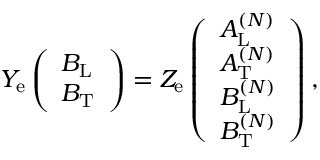<formula> <loc_0><loc_0><loc_500><loc_500>\begin{array} { r } { Y _ { e } \left ( \begin{array} { l } { B _ { L } } \\ { B _ { T } } \end{array} \right ) = Z _ { e } \left ( \begin{array} { l } { A _ { L } ^ { ( N ) } } \\ { A _ { T } ^ { ( N ) } } \\ { B _ { L } ^ { ( N ) } } \\ { B _ { T } ^ { ( N ) } } \end{array} \right ) , } \end{array}</formula> 